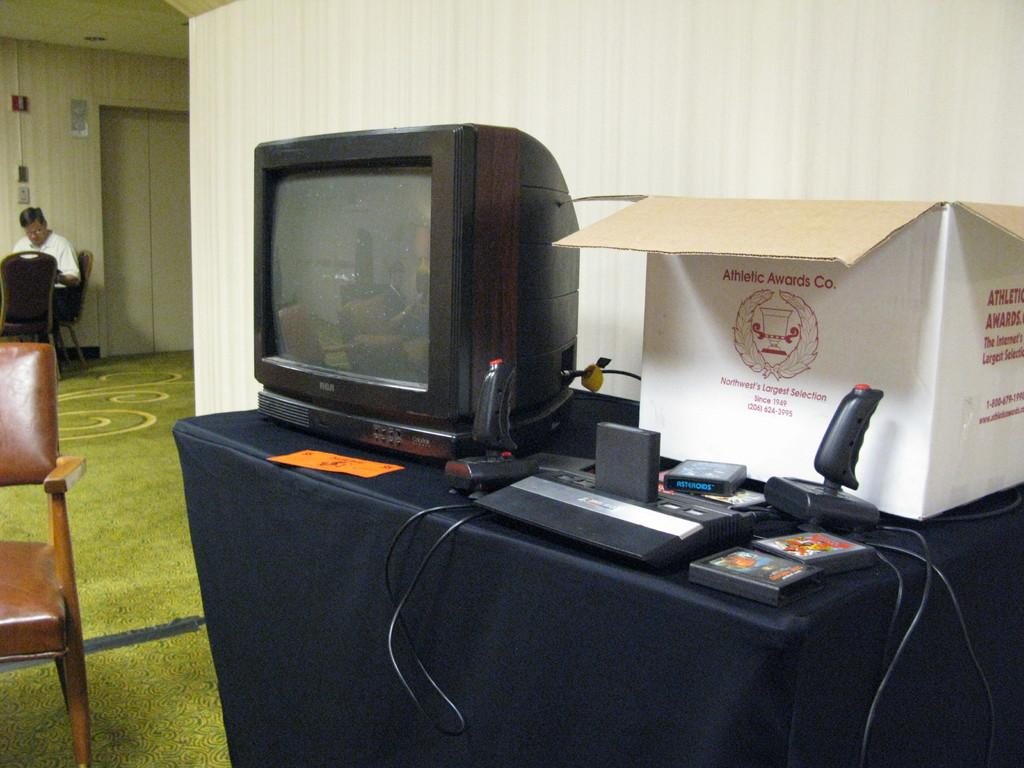<image>
Render a clear and concise summary of the photo. A white box from the Athletic Awards company sits next to an old television. 